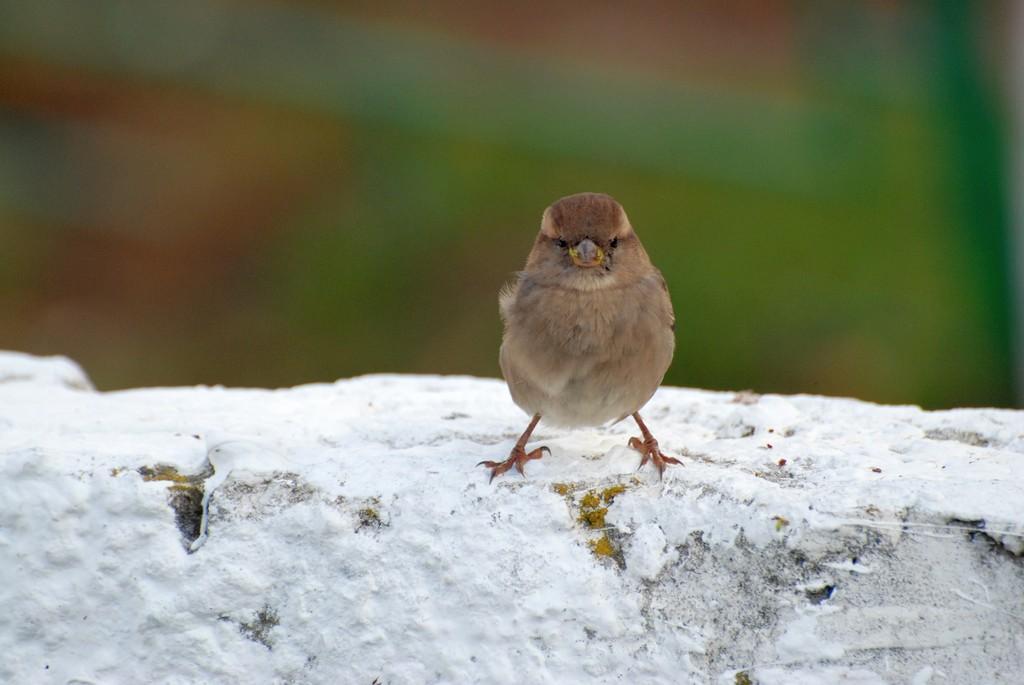Could you give a brief overview of what you see in this image? In this picture we can observe a bird which is in brown color on the wall. We can observe some snow on the wall. The background is completely blurred. 